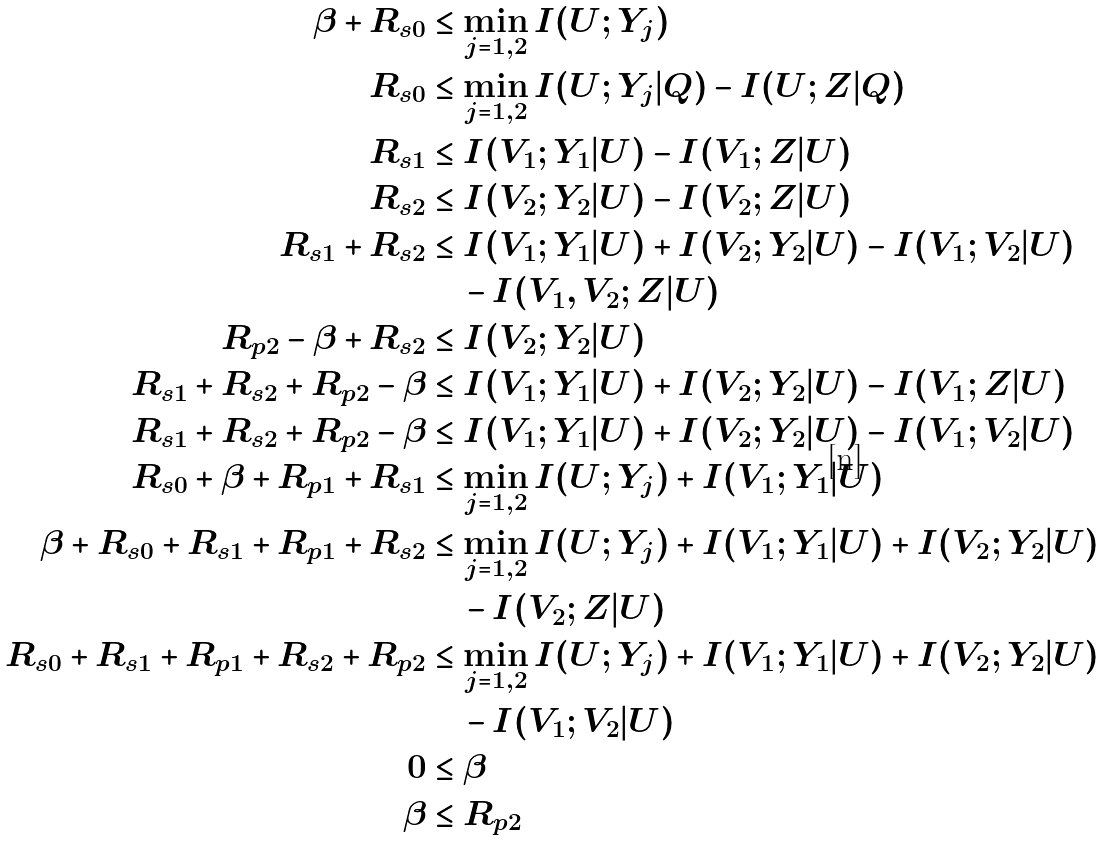<formula> <loc_0><loc_0><loc_500><loc_500>\beta + R _ { s 0 } & \leq \min _ { j = 1 , 2 } I ( U ; Y _ { j } ) \\ R _ { s 0 } & \leq \min _ { j = 1 , 2 } I ( U ; Y _ { j } | Q ) - I ( U ; Z | Q ) \\ R _ { s 1 } & \leq I ( V _ { 1 } ; Y _ { 1 } | U ) - I ( V _ { 1 } ; Z | U ) \\ R _ { s 2 } & \leq I ( V _ { 2 } ; Y _ { 2 } | U ) - I ( V _ { 2 } ; Z | U ) \\ R _ { s 1 } + R _ { s 2 } & \leq I ( V _ { 1 } ; Y _ { 1 } | U ) + I ( V _ { 2 } ; Y _ { 2 } | U ) - I ( V _ { 1 } ; V _ { 2 } | U ) \\ & \quad - I ( V _ { 1 } , V _ { 2 } ; Z | U ) \\ R _ { p 2 } - \beta + R _ { s 2 } & \leq I ( V _ { 2 } ; Y _ { 2 } | U ) \\ R _ { s 1 } + R _ { s 2 } + R _ { p 2 } - \beta & \leq I ( V _ { 1 } ; Y _ { 1 } | U ) + I ( V _ { 2 } ; Y _ { 2 } | U ) - I ( V _ { 1 } ; Z | U ) \\ R _ { s 1 } + R _ { s 2 } + R _ { p 2 } - \beta & \leq I ( V _ { 1 } ; Y _ { 1 } | U ) + I ( V _ { 2 } ; Y _ { 2 } | U ) - I ( V _ { 1 } ; V _ { 2 } | U ) \\ R _ { s 0 } + \beta + R _ { p 1 } + R _ { s 1 } & \leq \min _ { j = 1 , 2 } I ( U ; Y _ { j } ) + I ( V _ { 1 } ; Y _ { 1 } | U ) \\ \beta + R _ { s 0 } + R _ { s 1 } + R _ { p 1 } + R _ { s 2 } & \leq \min _ { j = 1 , 2 } I ( U ; Y _ { j } ) + I ( V _ { 1 } ; Y _ { 1 } | U ) + I ( V _ { 2 } ; Y _ { 2 } | U ) \\ & \quad - I ( V _ { 2 } ; Z | U ) \\ R _ { s 0 } + R _ { s 1 } + R _ { p 1 } + R _ { s 2 } + R _ { p 2 } & \leq \min _ { j = 1 , 2 } I ( U ; Y _ { j } ) + I ( V _ { 1 } ; Y _ { 1 } | U ) + I ( V _ { 2 } ; Y _ { 2 } | U ) \\ & \quad - I ( V _ { 1 } ; V _ { 2 } | U ) \\ 0 & \leq \beta \\ \beta & \leq R _ { p 2 }</formula> 